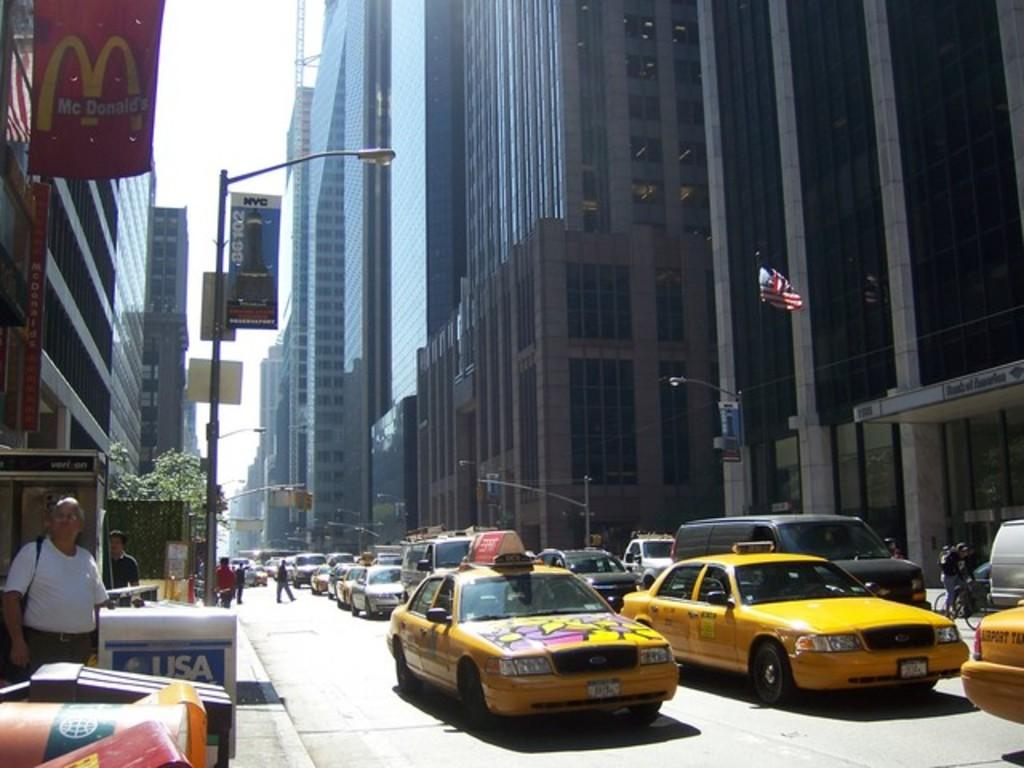<image>
Relay a brief, clear account of the picture shown. A busy street with taxi cabs on the road near a McDonalds sign. 